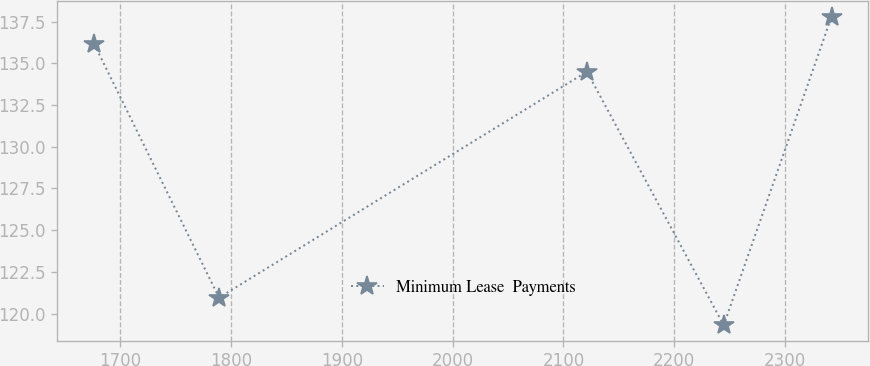<chart> <loc_0><loc_0><loc_500><loc_500><line_chart><ecel><fcel>Minimum Lease  Payments<nl><fcel>1676.72<fcel>136.15<nl><fcel>1789.36<fcel>120.96<nl><fcel>2121.27<fcel>134.5<nl><fcel>2244.61<fcel>119.31<nl><fcel>2341.93<fcel>137.8<nl></chart> 